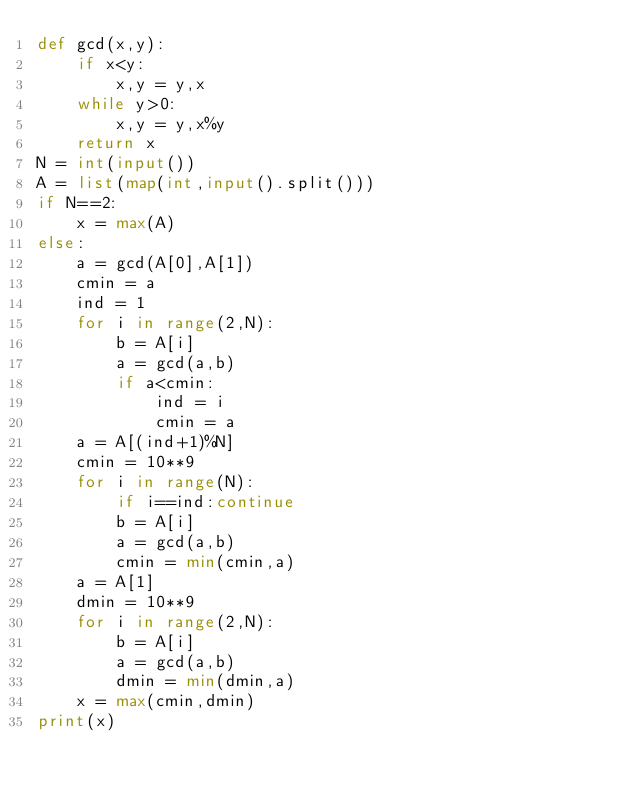Convert code to text. <code><loc_0><loc_0><loc_500><loc_500><_Python_>def gcd(x,y):
    if x<y:
        x,y = y,x
    while y>0:
        x,y = y,x%y
    return x
N = int(input())
A = list(map(int,input().split()))
if N==2:
    x = max(A)
else:
    a = gcd(A[0],A[1])
    cmin = a
    ind = 1
    for i in range(2,N):
        b = A[i]
        a = gcd(a,b)
        if a<cmin:
            ind = i
            cmin = a
    a = A[(ind+1)%N]
    cmin = 10**9
    for i in range(N):
        if i==ind:continue
        b = A[i]
        a = gcd(a,b)
        cmin = min(cmin,a)
    a = A[1]
    dmin = 10**9
    for i in range(2,N):
        b = A[i]
        a = gcd(a,b)
        dmin = min(dmin,a)
    x = max(cmin,dmin)
print(x)</code> 